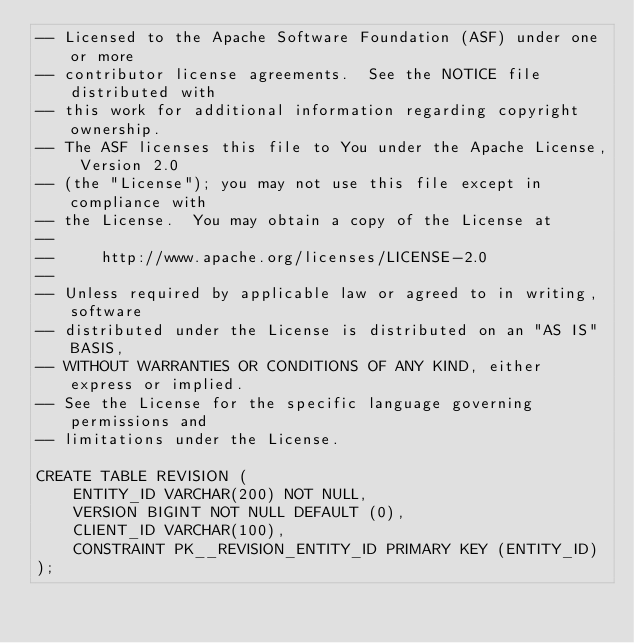Convert code to text. <code><loc_0><loc_0><loc_500><loc_500><_SQL_>-- Licensed to the Apache Software Foundation (ASF) under one or more
-- contributor license agreements.  See the NOTICE file distributed with
-- this work for additional information regarding copyright ownership.
-- The ASF licenses this file to You under the Apache License, Version 2.0
-- (the "License"); you may not use this file except in compliance with
-- the License.  You may obtain a copy of the License at
--
--     http://www.apache.org/licenses/LICENSE-2.0
--
-- Unless required by applicable law or agreed to in writing, software
-- distributed under the License is distributed on an "AS IS" BASIS,
-- WITHOUT WARRANTIES OR CONDITIONS OF ANY KIND, either express or implied.
-- See the License for the specific language governing permissions and
-- limitations under the License.

CREATE TABLE REVISION (
    ENTITY_ID VARCHAR(200) NOT NULL,
    VERSION BIGINT NOT NULL DEFAULT (0),
    CLIENT_ID VARCHAR(100),
    CONSTRAINT PK__REVISION_ENTITY_ID PRIMARY KEY (ENTITY_ID)
);</code> 